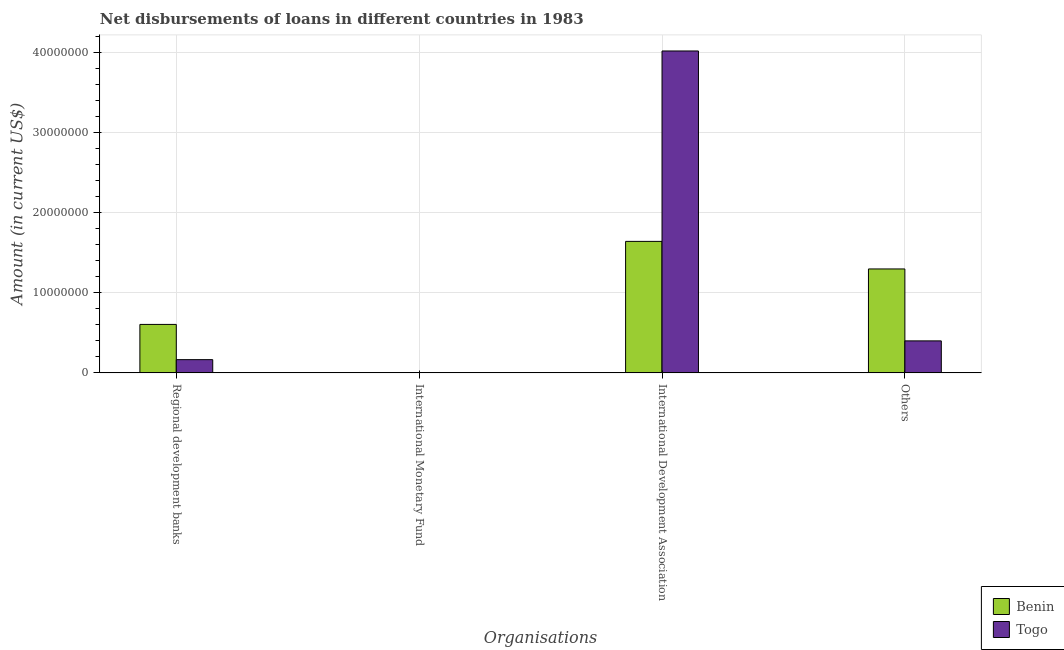How many bars are there on the 4th tick from the right?
Provide a succinct answer. 2. What is the label of the 4th group of bars from the left?
Keep it short and to the point. Others. What is the amount of loan disimbursed by regional development banks in Togo?
Provide a short and direct response. 1.65e+06. Across all countries, what is the maximum amount of loan disimbursed by regional development banks?
Keep it short and to the point. 6.06e+06. Across all countries, what is the minimum amount of loan disimbursed by international development association?
Your answer should be compact. 1.64e+07. In which country was the amount of loan disimbursed by regional development banks maximum?
Ensure brevity in your answer.  Benin. What is the total amount of loan disimbursed by international monetary fund in the graph?
Give a very brief answer. 0. What is the difference between the amount of loan disimbursed by regional development banks in Benin and that in Togo?
Provide a succinct answer. 4.40e+06. What is the difference between the amount of loan disimbursed by other organisations in Togo and the amount of loan disimbursed by international development association in Benin?
Provide a short and direct response. -1.24e+07. What is the average amount of loan disimbursed by regional development banks per country?
Make the answer very short. 3.86e+06. What is the difference between the amount of loan disimbursed by other organisations and amount of loan disimbursed by international development association in Benin?
Make the answer very short. -3.45e+06. In how many countries, is the amount of loan disimbursed by international development association greater than 38000000 US$?
Keep it short and to the point. 1. What is the ratio of the amount of loan disimbursed by other organisations in Togo to that in Benin?
Your answer should be very brief. 0.31. Is the amount of loan disimbursed by international development association in Benin less than that in Togo?
Provide a short and direct response. Yes. What is the difference between the highest and the second highest amount of loan disimbursed by international development association?
Provide a succinct answer. 2.38e+07. What is the difference between the highest and the lowest amount of loan disimbursed by other organisations?
Ensure brevity in your answer.  9.00e+06. Is the sum of the amount of loan disimbursed by regional development banks in Togo and Benin greater than the maximum amount of loan disimbursed by international development association across all countries?
Your answer should be very brief. No. How many countries are there in the graph?
Make the answer very short. 2. Are the values on the major ticks of Y-axis written in scientific E-notation?
Offer a terse response. No. Does the graph contain grids?
Keep it short and to the point. Yes. How are the legend labels stacked?
Offer a terse response. Vertical. What is the title of the graph?
Offer a very short reply. Net disbursements of loans in different countries in 1983. Does "China" appear as one of the legend labels in the graph?
Make the answer very short. No. What is the label or title of the X-axis?
Your answer should be compact. Organisations. What is the Amount (in current US$) of Benin in Regional development banks?
Offer a terse response. 6.06e+06. What is the Amount (in current US$) in Togo in Regional development banks?
Give a very brief answer. 1.65e+06. What is the Amount (in current US$) in Benin in International Development Association?
Provide a short and direct response. 1.64e+07. What is the Amount (in current US$) of Togo in International Development Association?
Your response must be concise. 4.02e+07. What is the Amount (in current US$) in Benin in Others?
Your response must be concise. 1.30e+07. What is the Amount (in current US$) of Togo in Others?
Provide a short and direct response. 4.00e+06. Across all Organisations, what is the maximum Amount (in current US$) of Benin?
Offer a very short reply. 1.64e+07. Across all Organisations, what is the maximum Amount (in current US$) of Togo?
Provide a succinct answer. 4.02e+07. Across all Organisations, what is the minimum Amount (in current US$) in Togo?
Offer a very short reply. 0. What is the total Amount (in current US$) of Benin in the graph?
Ensure brevity in your answer.  3.55e+07. What is the total Amount (in current US$) of Togo in the graph?
Your response must be concise. 4.59e+07. What is the difference between the Amount (in current US$) in Benin in Regional development banks and that in International Development Association?
Offer a very short reply. -1.04e+07. What is the difference between the Amount (in current US$) in Togo in Regional development banks and that in International Development Association?
Make the answer very short. -3.86e+07. What is the difference between the Amount (in current US$) of Benin in Regional development banks and that in Others?
Your answer should be very brief. -6.94e+06. What is the difference between the Amount (in current US$) in Togo in Regional development banks and that in Others?
Keep it short and to the point. -2.35e+06. What is the difference between the Amount (in current US$) in Benin in International Development Association and that in Others?
Keep it short and to the point. 3.45e+06. What is the difference between the Amount (in current US$) of Togo in International Development Association and that in Others?
Offer a terse response. 3.62e+07. What is the difference between the Amount (in current US$) of Benin in Regional development banks and the Amount (in current US$) of Togo in International Development Association?
Offer a very short reply. -3.42e+07. What is the difference between the Amount (in current US$) in Benin in Regional development banks and the Amount (in current US$) in Togo in Others?
Provide a succinct answer. 2.06e+06. What is the difference between the Amount (in current US$) of Benin in International Development Association and the Amount (in current US$) of Togo in Others?
Your response must be concise. 1.24e+07. What is the average Amount (in current US$) in Benin per Organisations?
Your answer should be compact. 8.87e+06. What is the average Amount (in current US$) in Togo per Organisations?
Keep it short and to the point. 1.15e+07. What is the difference between the Amount (in current US$) in Benin and Amount (in current US$) in Togo in Regional development banks?
Keep it short and to the point. 4.40e+06. What is the difference between the Amount (in current US$) of Benin and Amount (in current US$) of Togo in International Development Association?
Provide a short and direct response. -2.38e+07. What is the difference between the Amount (in current US$) in Benin and Amount (in current US$) in Togo in Others?
Offer a very short reply. 9.00e+06. What is the ratio of the Amount (in current US$) of Benin in Regional development banks to that in International Development Association?
Offer a very short reply. 0.37. What is the ratio of the Amount (in current US$) of Togo in Regional development banks to that in International Development Association?
Provide a succinct answer. 0.04. What is the ratio of the Amount (in current US$) in Benin in Regional development banks to that in Others?
Provide a short and direct response. 0.47. What is the ratio of the Amount (in current US$) of Togo in Regional development banks to that in Others?
Give a very brief answer. 0.41. What is the ratio of the Amount (in current US$) in Benin in International Development Association to that in Others?
Offer a terse response. 1.27. What is the ratio of the Amount (in current US$) in Togo in International Development Association to that in Others?
Ensure brevity in your answer.  10.06. What is the difference between the highest and the second highest Amount (in current US$) of Benin?
Provide a short and direct response. 3.45e+06. What is the difference between the highest and the second highest Amount (in current US$) of Togo?
Keep it short and to the point. 3.62e+07. What is the difference between the highest and the lowest Amount (in current US$) of Benin?
Keep it short and to the point. 1.64e+07. What is the difference between the highest and the lowest Amount (in current US$) of Togo?
Keep it short and to the point. 4.02e+07. 